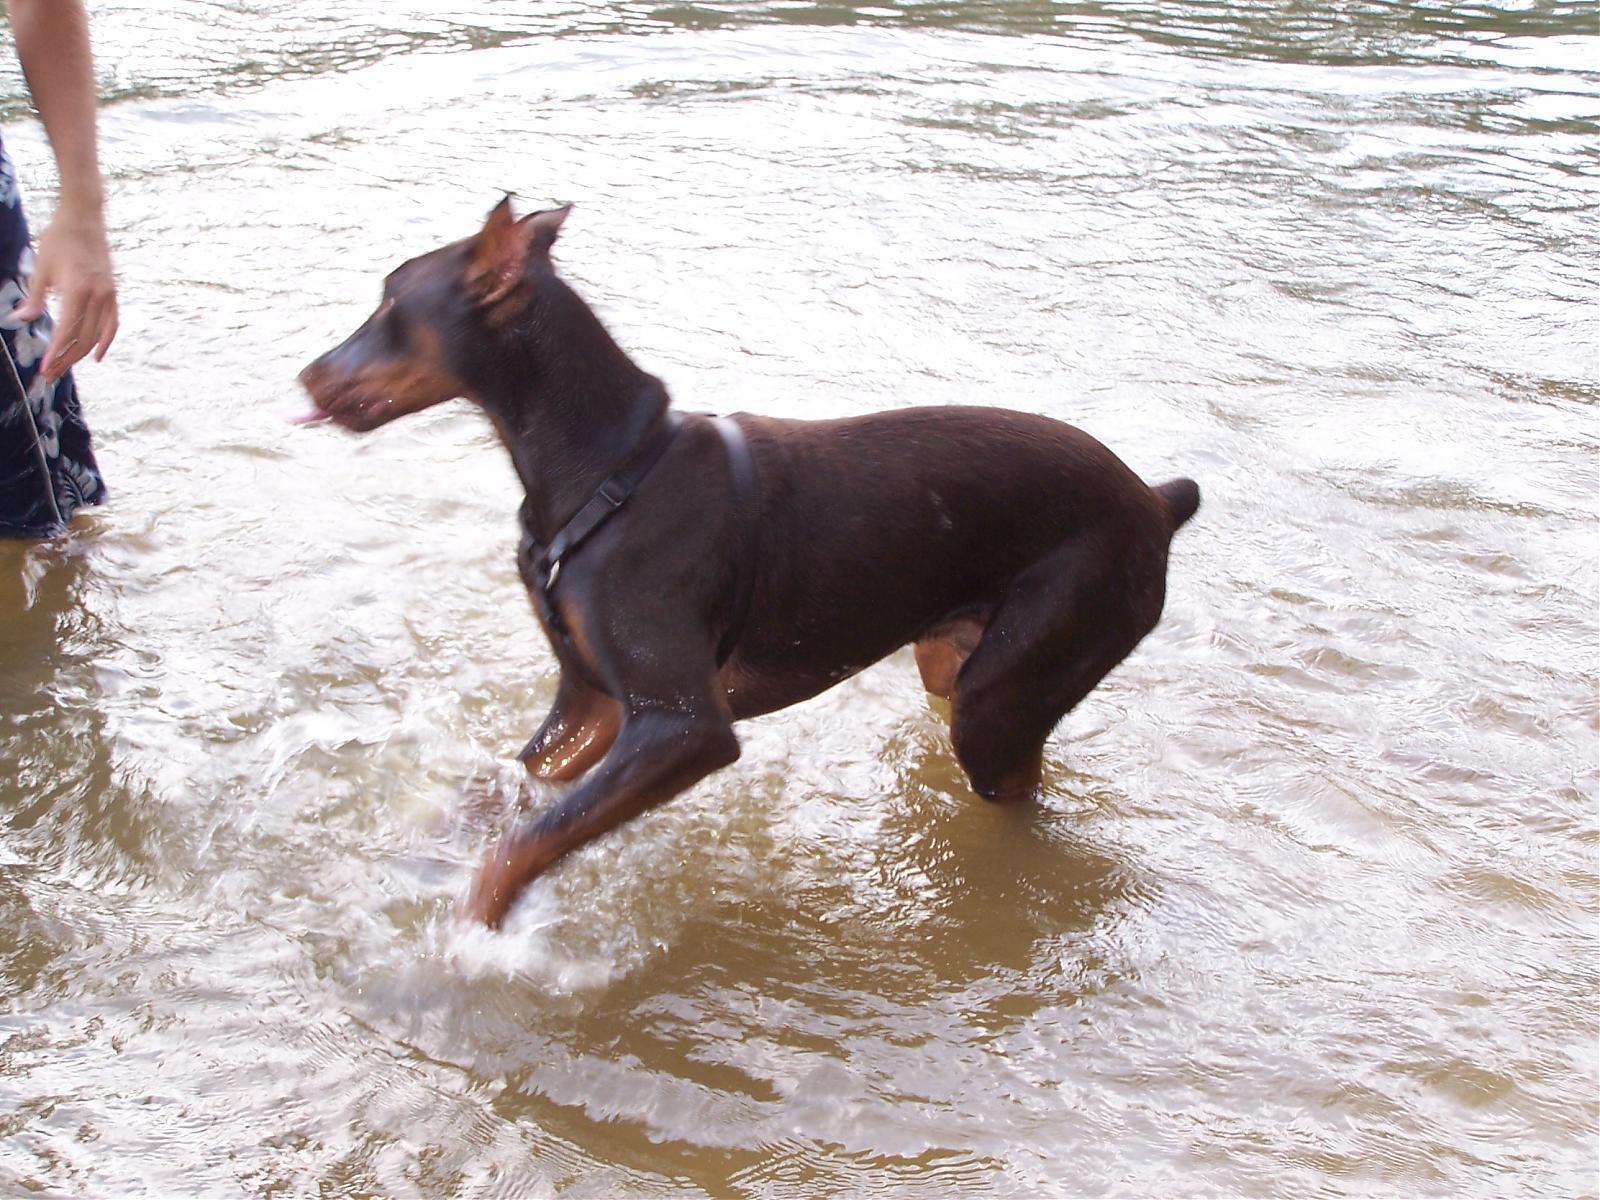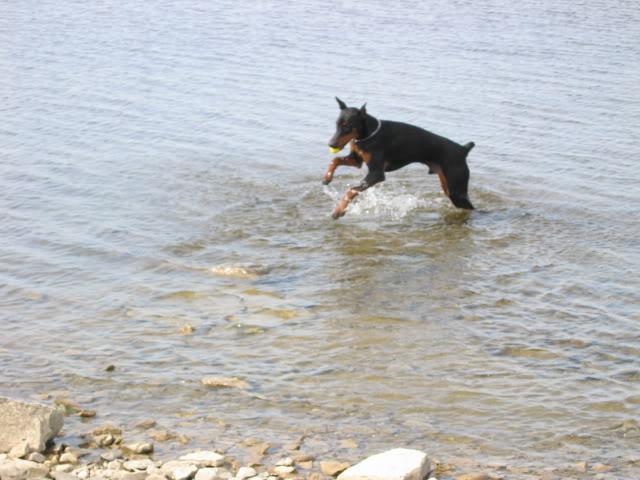The first image is the image on the left, the second image is the image on the right. Analyze the images presented: Is the assertion "Three or more mammals are visible." valid? Answer yes or no. Yes. The first image is the image on the left, the second image is the image on the right. Considering the images on both sides, is "The right image shows a left-facing doberman creating a splash, with its front paws off the ground." valid? Answer yes or no. Yes. 